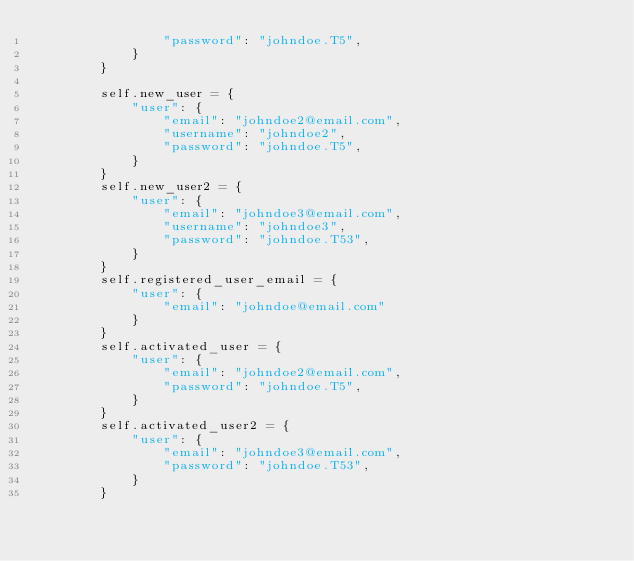Convert code to text. <code><loc_0><loc_0><loc_500><loc_500><_Python_>                "password": "johndoe.T5",
            }
        }

        self.new_user = {
            "user": {
                "email": "johndoe2@email.com",
                "username": "johndoe2",
                "password": "johndoe.T5",
            }
        }
        self.new_user2 = {
            "user": {
                "email": "johndoe3@email.com",
                "username": "johndoe3",
                "password": "johndoe.T53",
            }
        }
        self.registered_user_email = {
            "user": {
                "email": "johndoe@email.com"
            }
        }
        self.activated_user = {
            "user": {
                "email": "johndoe2@email.com",
                "password": "johndoe.T5",
            }
        }
        self.activated_user2 = {
            "user": {
                "email": "johndoe3@email.com",
                "password": "johndoe.T53",
            }
        }
</code> 